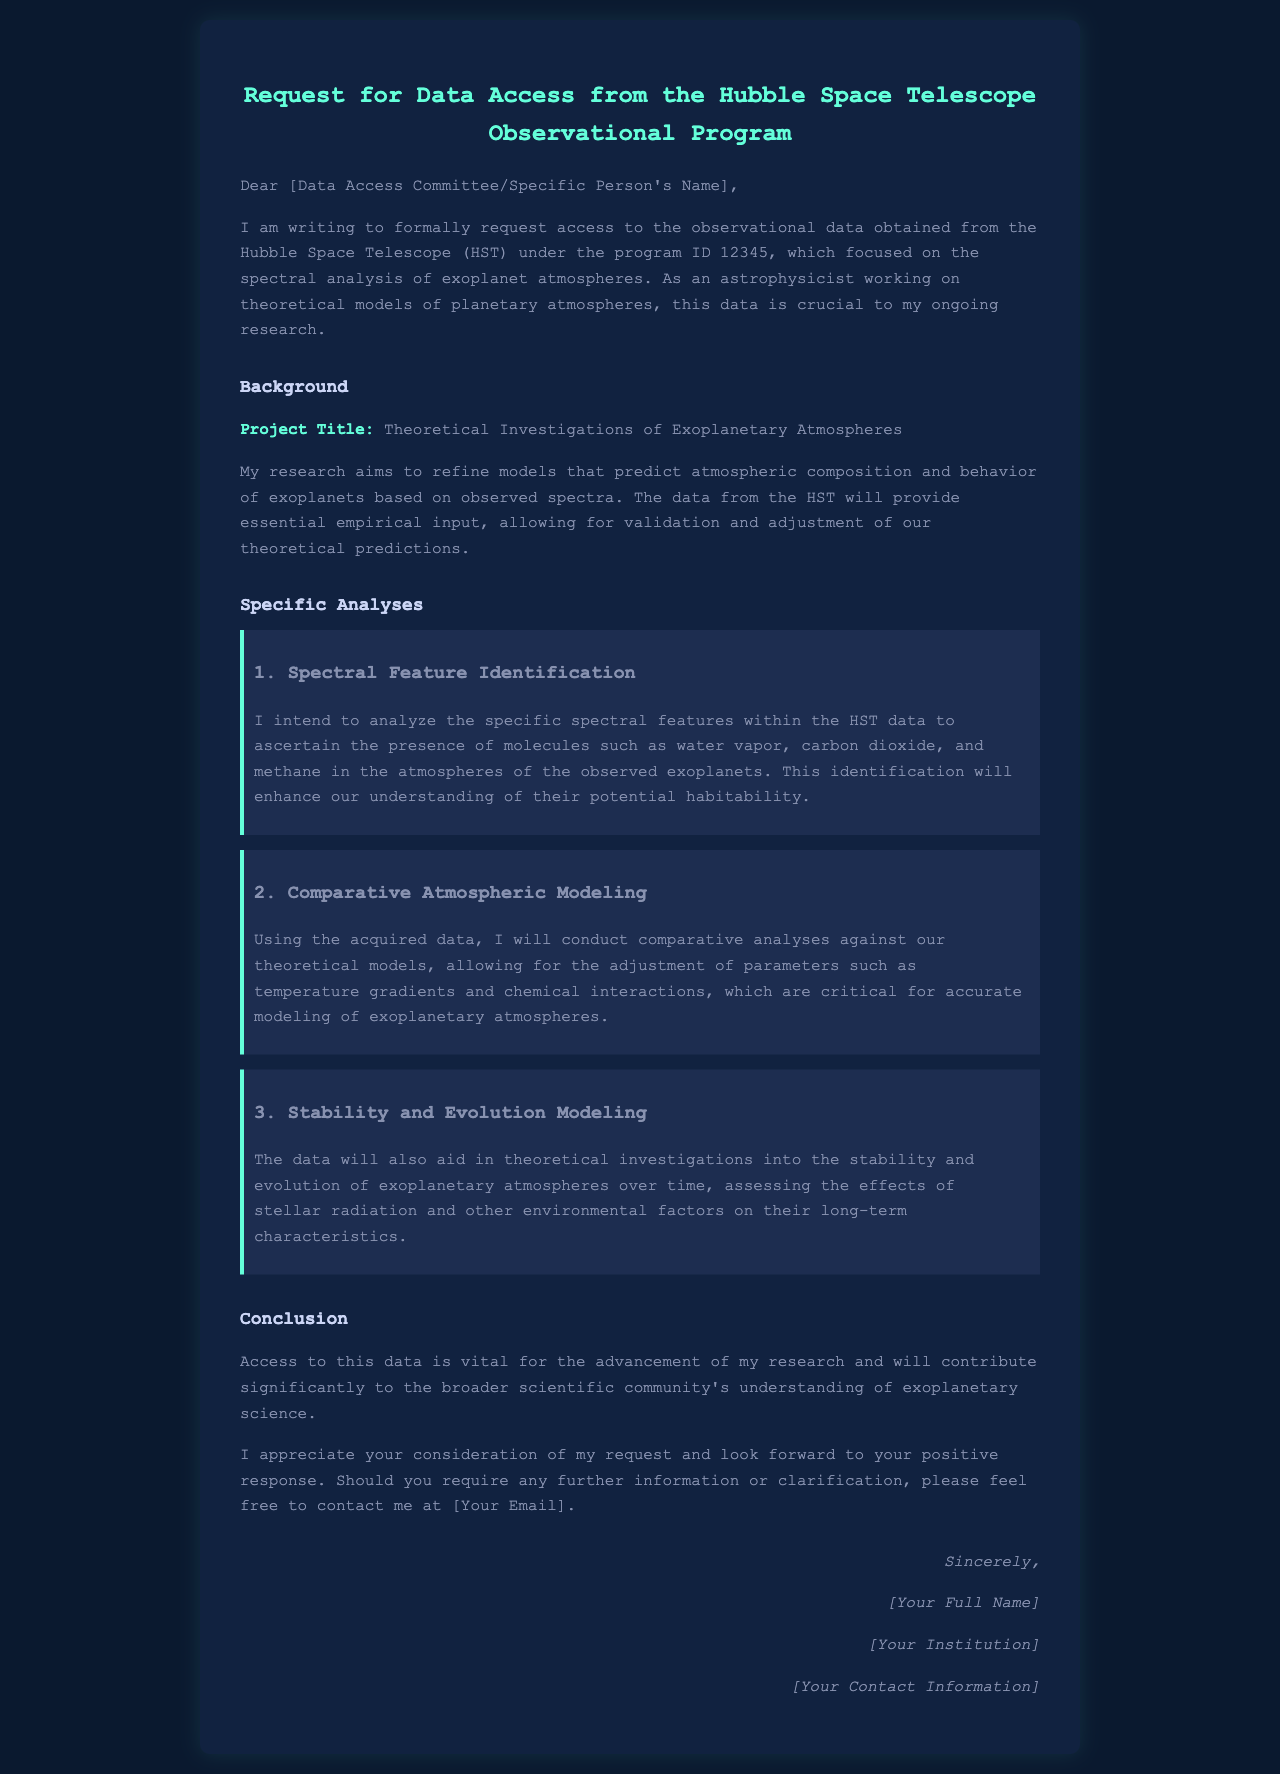What is the program ID for the HST observational data? The program ID is mentioned in the request, which is 12345.
Answer: 12345 What is the project title of the research? The project title is stated in the background section as "Theoretical Investigations of Exoplanetary Atmospheres."
Answer: Theoretical Investigations of Exoplanetary Atmospheres Which molecules does the analysis aim to identify in the exoplanet atmospheres? The request specifies water vapor, carbon dioxide, and methane as the molecules of interest.
Answer: Water vapor, carbon dioxide, and methane What type of modeling will be conducted with the acquired data? The document refers to "Comparative Atmospheric Modeling" as one of the analyses intended with the data.
Answer: Comparative Atmospheric Modeling What is the main purpose of accessing the HST data according to the document? The main purpose is to enhance the understanding of exoplanetary science and the author's research.
Answer: To enhance understanding of exoplanetary science How many specific analyses are mentioned in the request? The request outlines three specific analyses that the author intends to conduct with the data.
Answer: Three Who is the intended recipient of the letter? The letter is directed to the "Data Access Committee" or a specific person's name if provided.
Answer: Data Access Committee What is the overall tone of the conclusion in the request? The conclusion expresses appreciation for the consideration of the request and a hopeful anticipation of a positive response.
Answer: Appreciative and hopeful 